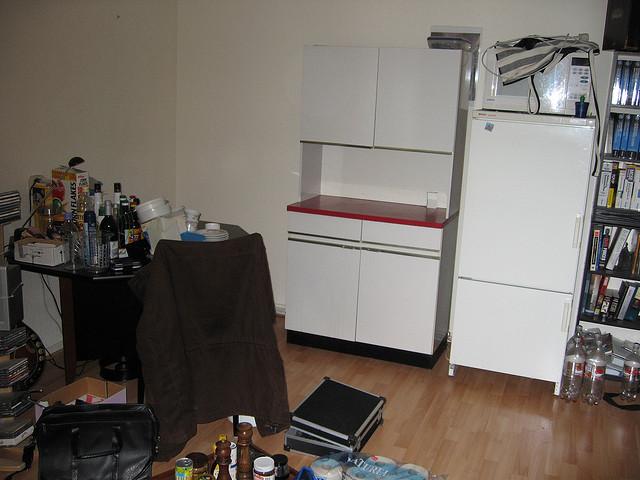How many pieces of luggage are red?
Write a very short answer. 0. What color is the counter?
Answer briefly. Red. What is sitting on top of the refrigerator?
Answer briefly. Microwave. Is this a business office?
Keep it brief. No. What is the color of the fridge?
Write a very short answer. White. Is this a messy place?
Answer briefly. Yes. How many chairs are there?
Answer briefly. 1. What is above the stove?
Answer briefly. No stove. 